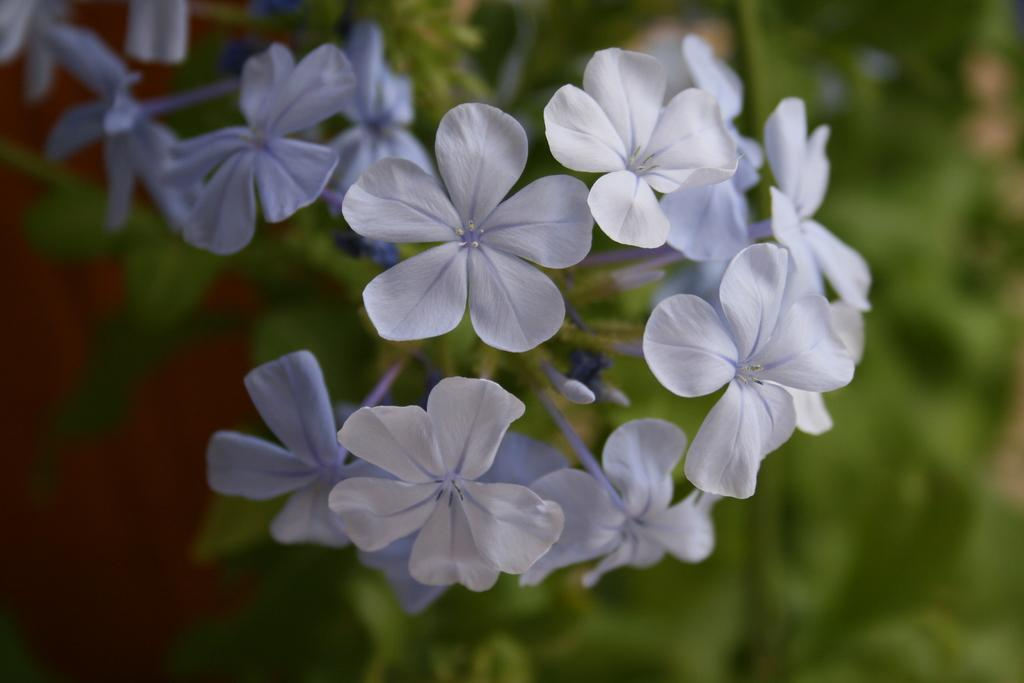What type of plants can be seen in the image? There are flowers in the image. How would you describe the background of the image? The background of the image is blurry. What type of reward is being discussed in the meeting in the image? There is no meeting or reward present in the image; it only features flowers and a blurry background. 